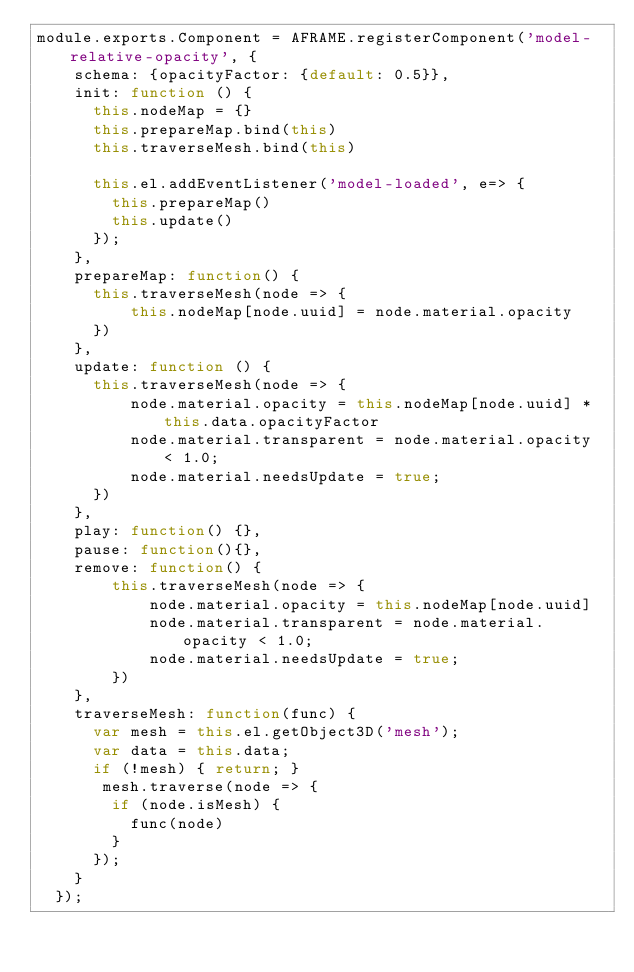Convert code to text. <code><loc_0><loc_0><loc_500><loc_500><_JavaScript_>module.exports.Component = AFRAME.registerComponent('model-relative-opacity', {
    schema: {opacityFactor: {default: 0.5}},
    init: function () {
      this.nodeMap = {}
      this.prepareMap.bind(this)
      this.traverseMesh.bind(this)

      this.el.addEventListener('model-loaded', e=> {
        this.prepareMap()
        this.update()
      });
    },
    prepareMap: function() {
      this.traverseMesh(node => {
          this.nodeMap[node.uuid] = node.material.opacity
      })
    },
    update: function () {
      this.traverseMesh(node => {
          node.material.opacity = this.nodeMap[node.uuid] * this.data.opacityFactor
          node.material.transparent = node.material.opacity < 1.0;
          node.material.needsUpdate = true;
      })
    },
    play: function() {},
    pause: function(){},
    remove: function() {
        this.traverseMesh(node => {
            node.material.opacity = this.nodeMap[node.uuid]
            node.material.transparent = node.material.opacity < 1.0;
            node.material.needsUpdate = true;
        })
    },
    traverseMesh: function(func) {
      var mesh = this.el.getObject3D('mesh');
      var data = this.data;
      if (!mesh) { return; }
       mesh.traverse(node => {
        if (node.isMesh) {
          func(node)
        }
      }); 
    }
  });</code> 